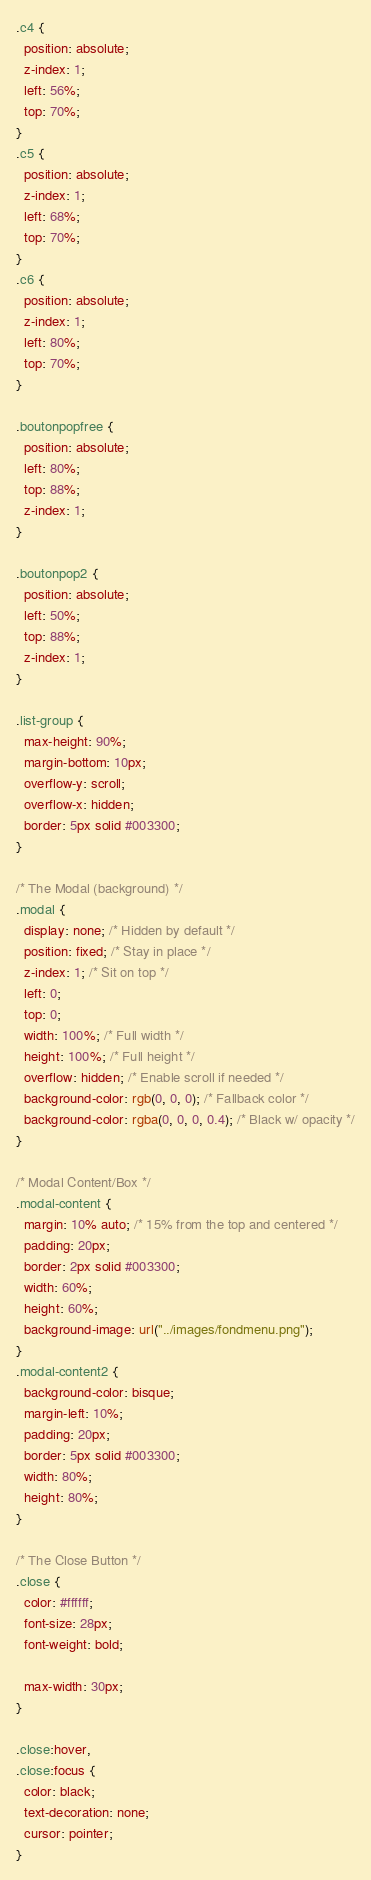Convert code to text. <code><loc_0><loc_0><loc_500><loc_500><_CSS_>.c4 {
  position: absolute;
  z-index: 1;
  left: 56%;
  top: 70%;
}
.c5 {
  position: absolute;
  z-index: 1;
  left: 68%;
  top: 70%;
}
.c6 {
  position: absolute;
  z-index: 1;
  left: 80%;
  top: 70%;
}

.boutonpopfree {
  position: absolute;
  left: 80%;
  top: 88%;
  z-index: 1;
}

.boutonpop2 {
  position: absolute;
  left: 50%;
  top: 88%;
  z-index: 1;
}

.list-group {
  max-height: 90%;
  margin-bottom: 10px;
  overflow-y: scroll;
  overflow-x: hidden;
  border: 5px solid #003300;
}

/* The Modal (background) */
.modal {
  display: none; /* Hidden by default */
  position: fixed; /* Stay in place */
  z-index: 1; /* Sit on top */
  left: 0;
  top: 0;
  width: 100%; /* Full width */
  height: 100%; /* Full height */
  overflow: hidden; /* Enable scroll if needed */
  background-color: rgb(0, 0, 0); /* Fallback color */
  background-color: rgba(0, 0, 0, 0.4); /* Black w/ opacity */
}

/* Modal Content/Box */
.modal-content {
  margin: 10% auto; /* 15% from the top and centered */
  padding: 20px;
  border: 2px solid #003300;
  width: 60%;
  height: 60%;
  background-image: url("../images/fondmenu.png");
}
.modal-content2 {
  background-color: bisque;
  margin-left: 10%;
  padding: 20px;
  border: 5px solid #003300;
  width: 80%;
  height: 80%;
}

/* The Close Button */
.close {
  color: #ffffff;
  font-size: 28px;
  font-weight: bold;

  max-width: 30px;
}

.close:hover,
.close:focus {
  color: black;
  text-decoration: none;
  cursor: pointer;
}
</code> 